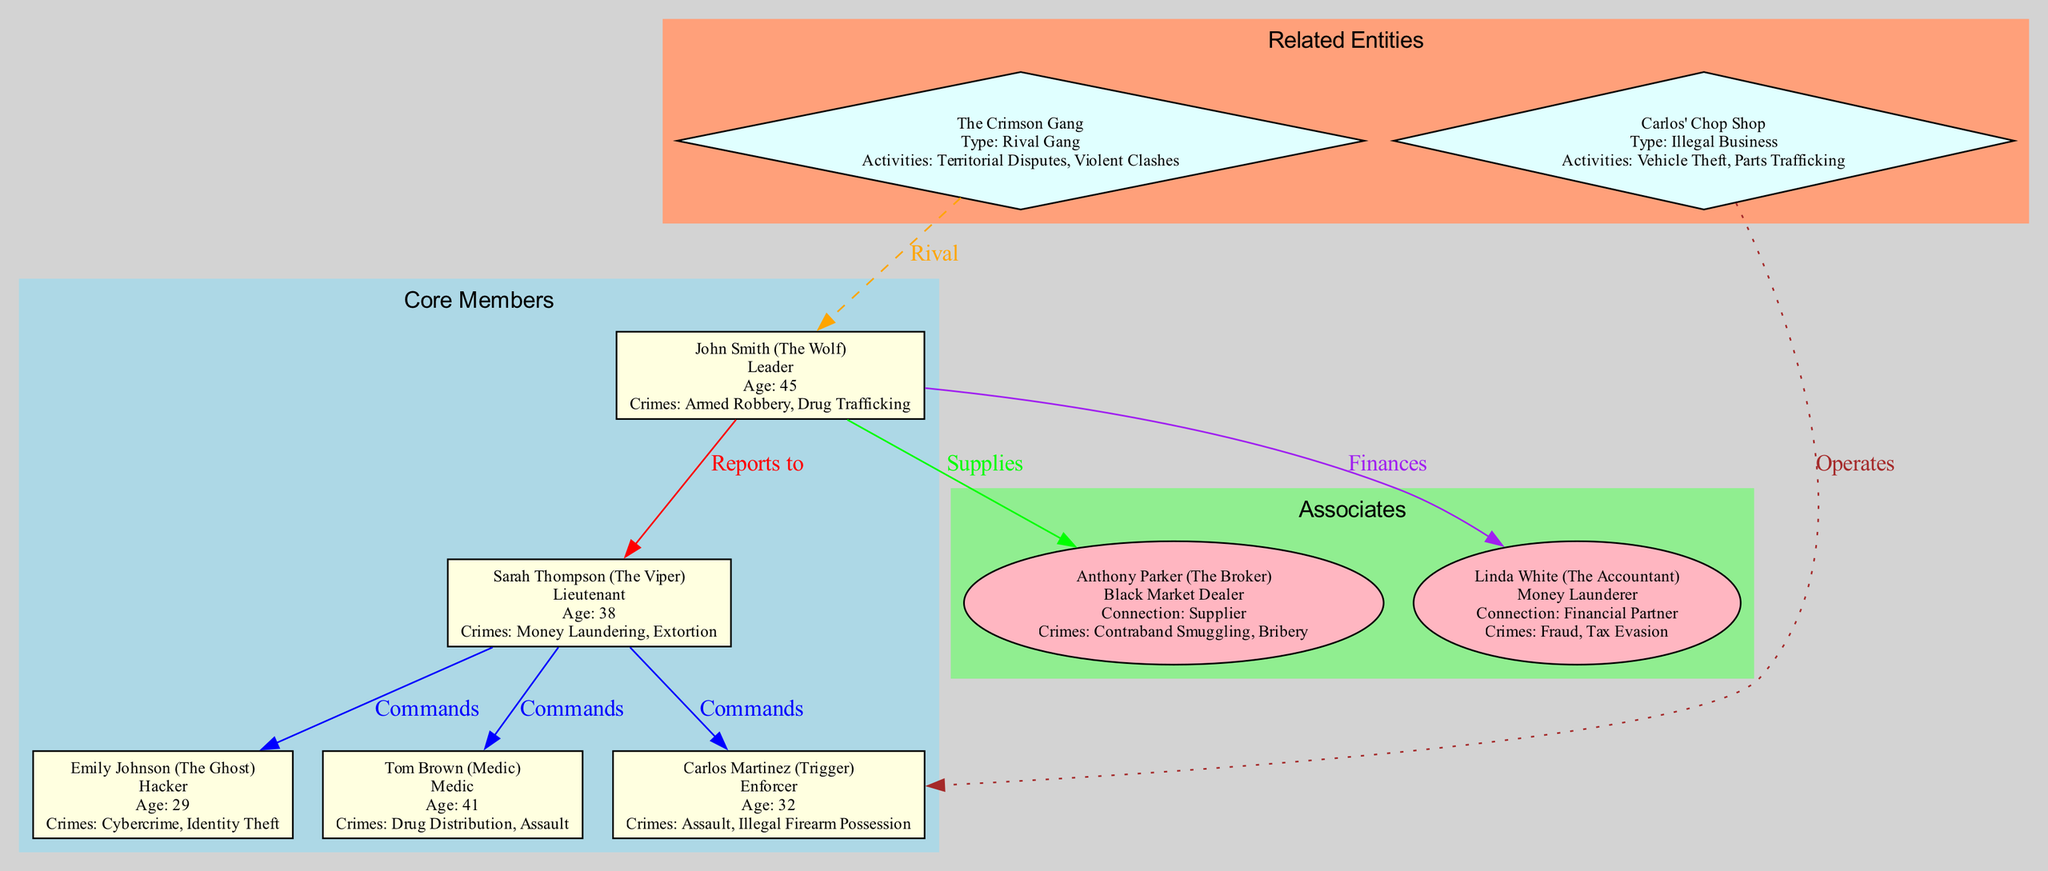What is the alias of John Smith? The diagram clearly shows John Smith's alias listed alongside his name, indicating that he is known as "The Wolf."
Answer: The Wolf How many core members are in the criminal network? By counting the individual nodes within the "Core Members" subgraph, we find there are five individuals: John Smith, Sarah Thompson, Carlos Martinez, Emily Johnson, and Tom Brown.
Answer: 5 Who reports to Sarah Thompson? The edges connected to Sarah Thompson indicate that Carlos Martinez, Emily Johnson, and Tom Brown all report to her, showcasing her command role within the network.
Answer: Carlos Martinez, Emily Johnson, Tom Brown What type of activities is Carlos' Chop Shop involved in? The node for Carlos' Chop Shop explicitly states that its criminal activities include "Vehicle Theft" and "Parts Trafficking," which answers the question directly regarding what type of activities it conducts.
Answer: Vehicle Theft, Parts Trafficking Which individual has the alias "The Viper"? In the diagram, the information for Sarah Thompson shows her alias as "The Viper," linking the individual to their street name within the network.
Answer: The Viper Who is John Smith's main supplier? The diagram illustrates an edge labeled "Supplies" connecting John Smith to Anthony Parker, indicating that Anthony is his primary supplier in the criminal network.
Answer: Anthony Parker Which entity is considered a rival gang? The node labeled "The Crimson Gang" in the "Related Entities" subgraph identifies it as a rival gang involved in criminal activities associated with territorial disputes and violent clashes.
Answer: The Crimson Gang What is the connection type of Linda White to John Smith? The diagram depicts an edge labeled "Finances" linking John Smith to Linda White, indicating that her role is as a financial partner to John Smith.
Answer: Financial Partner What is the role of Emily Johnson in the criminal network? Within the "Core Members" subsection, Emily Johnson’s role is indicated as "Hacker," detailing her function within the criminal organization.
Answer: Hacker 